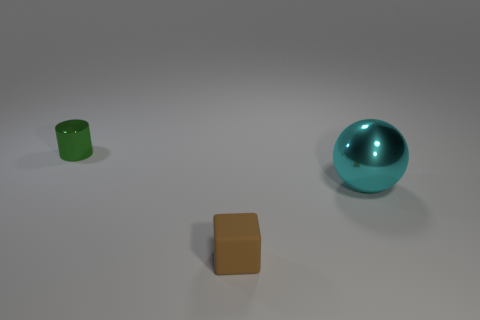Could you describe the lighting in the scene? The lighting in the scene is bright and diffused, casting soft shadows. It appears as if there is a uniform overhead light source illuminating the entire scene uniformly. 